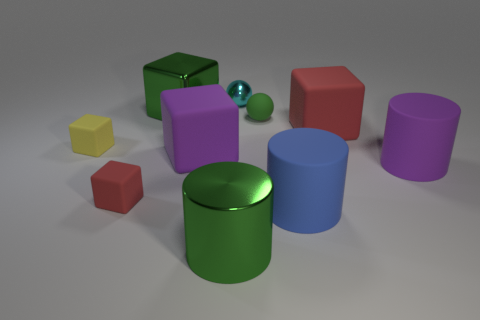There is a large block that is in front of the tiny green thing and left of the blue rubber object; what material is it made of?
Your answer should be very brief. Rubber. What number of matte cubes are the same size as the cyan ball?
Provide a succinct answer. 2. There is another red object that is the same shape as the big red matte object; what is it made of?
Offer a very short reply. Rubber. What number of objects are big objects behind the large green cylinder or small things in front of the shiny sphere?
Keep it short and to the point. 8. Does the tiny green matte object have the same shape as the large shiny thing on the left side of the large purple block?
Give a very brief answer. No. There is a big green thing that is to the left of the green thing in front of the tiny rubber cube right of the yellow cube; what is its shape?
Give a very brief answer. Cube. What number of other objects are there of the same material as the yellow object?
Provide a succinct answer. 6. What number of objects are red rubber blocks that are on the right side of the blue cylinder or large green shiny things?
Offer a very short reply. 3. There is a thing that is in front of the big blue cylinder that is left of the purple cylinder; what shape is it?
Offer a very short reply. Cylinder. Do the object that is in front of the big blue rubber thing and the tiny cyan metallic object have the same shape?
Offer a terse response. No. 